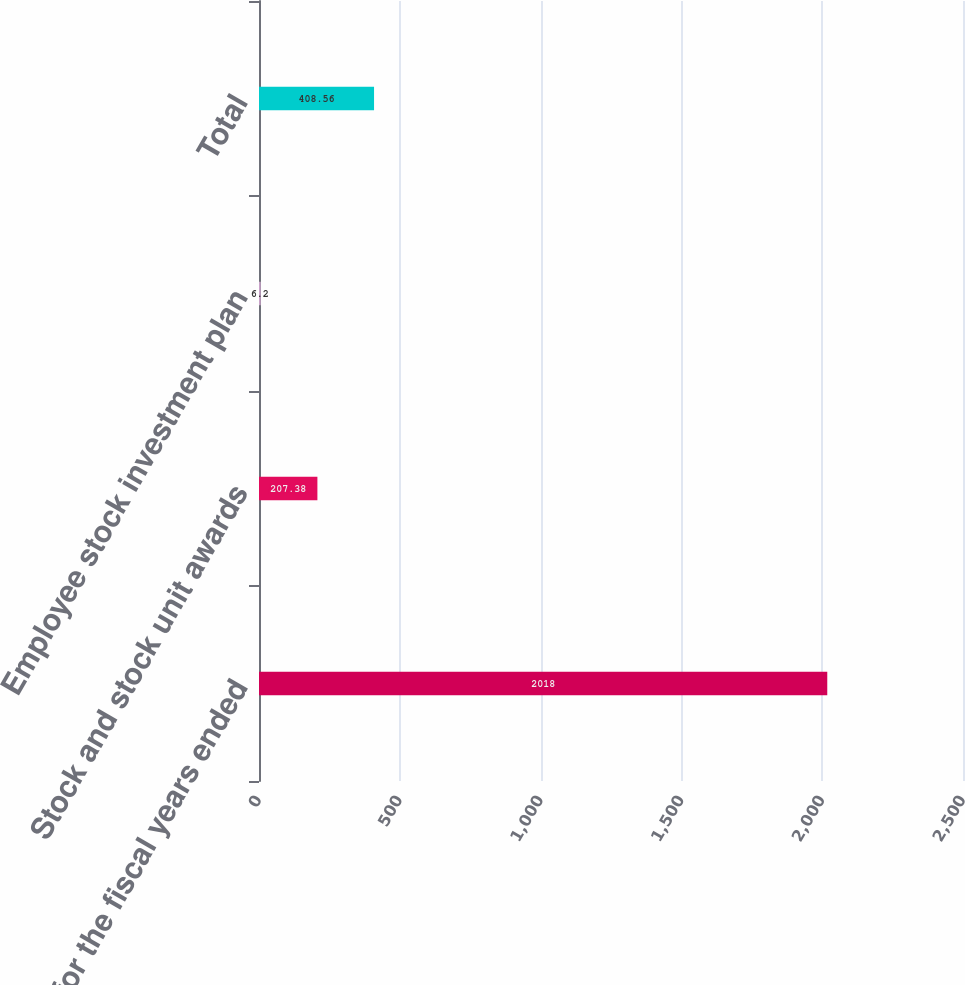<chart> <loc_0><loc_0><loc_500><loc_500><bar_chart><fcel>for the fiscal years ended<fcel>Stock and stock unit awards<fcel>Employee stock investment plan<fcel>Total<nl><fcel>2018<fcel>207.38<fcel>6.2<fcel>408.56<nl></chart> 